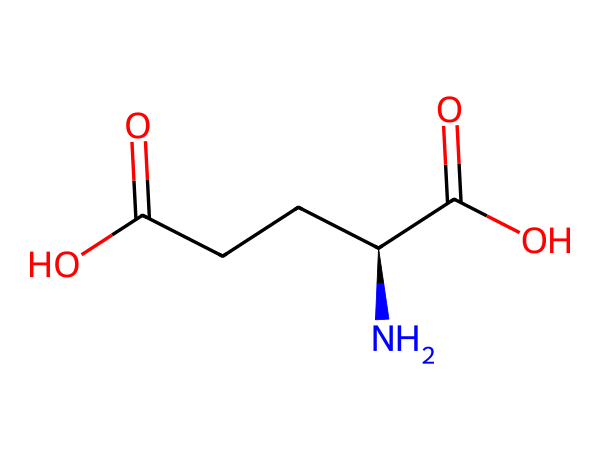What is the molecular formula of this chemical? This chemical structure contains 5 carbon (C) atoms, 9 hydrogen (H) atoms, 2 oxygen (O) atoms, and 1 nitrogen (N) atom. By counting all these, the molecular formula can be written as C5H9N1O2.
Answer: C5H9NO2 How many chiral centers are present in this molecule? The given structure has one chiral center, which is indicated by the presence of a carbon atom bound to four different substituents (the amino group, carboxyl group, and carbon chain).
Answer: 1 What type of functional groups are present in this molecule? A careful examination of the structure reveals an amino group (-NH2) and two carboxylic acid groups (-COOH). These groups are responsible for the chemical's classification as an amino acid.
Answer: amino and carboxylic acid What type of acid is represented by this structure? This structure represents a type of amino acid known as a carboxylic acid because it contains a carboxyl functional group (-COOH) and can donate protons (H+).
Answer: carboxylic acid Explain the significance of the amino group in this chemical. The amino group in this molecule is essential because it is responsible for the compound's classification as an amino acid and plays a crucial role in protein synthesis and neurotransmission. It influences the molecule's ability to participate in biological processes such as synaptic plasticity.
Answer: protein synthesis and neurotransmission 